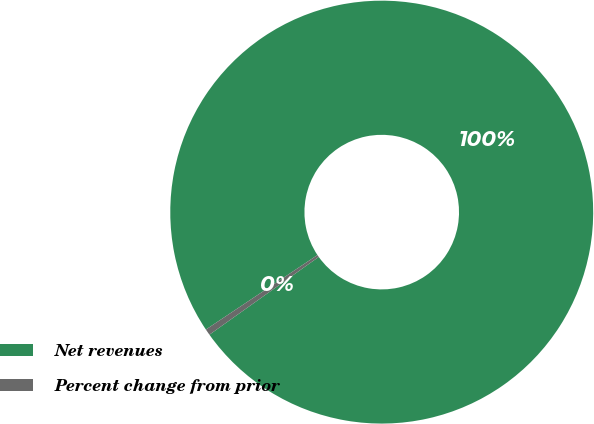Convert chart to OTSL. <chart><loc_0><loc_0><loc_500><loc_500><pie_chart><fcel>Net revenues<fcel>Percent change from prior<nl><fcel>99.53%<fcel>0.47%<nl></chart> 